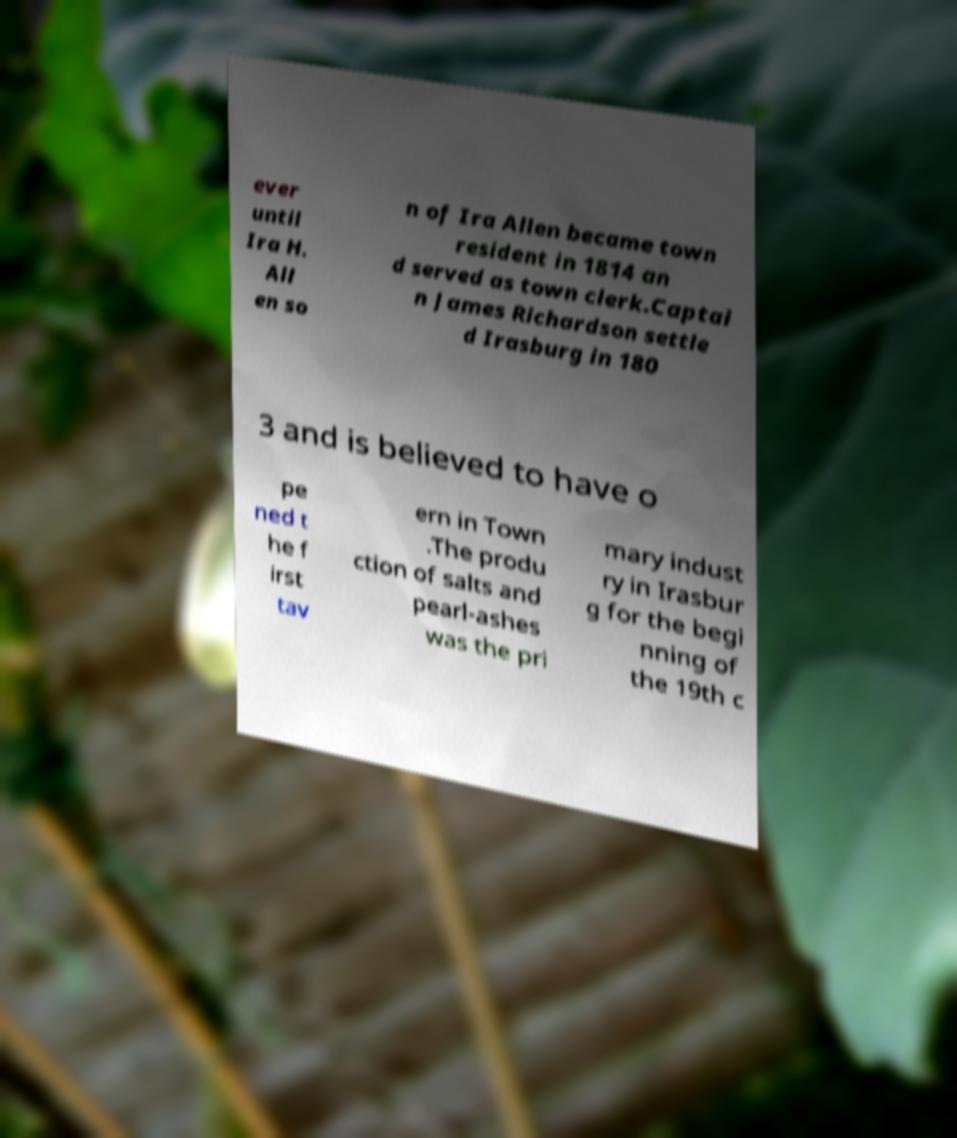Could you assist in decoding the text presented in this image and type it out clearly? ever until Ira H. All en so n of Ira Allen became town resident in 1814 an d served as town clerk.Captai n James Richardson settle d Irasburg in 180 3 and is believed to have o pe ned t he f irst tav ern in Town .The produ ction of salts and pearl-ashes was the pri mary indust ry in Irasbur g for the begi nning of the 19th c 